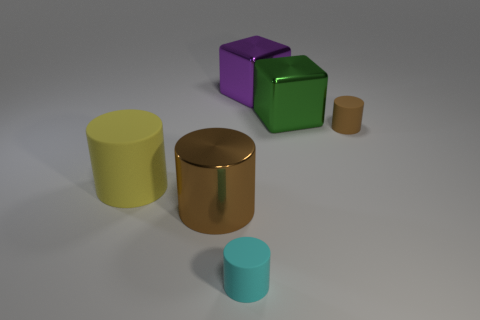What could be the purpose of these objects? These objects seem to be geometric shapes rendered in 3D for illustrative or educational purposes. They could be used in a variety of contexts such as graphic design, educational materials to teach geometry, or as objects in a video game for environment setting. 